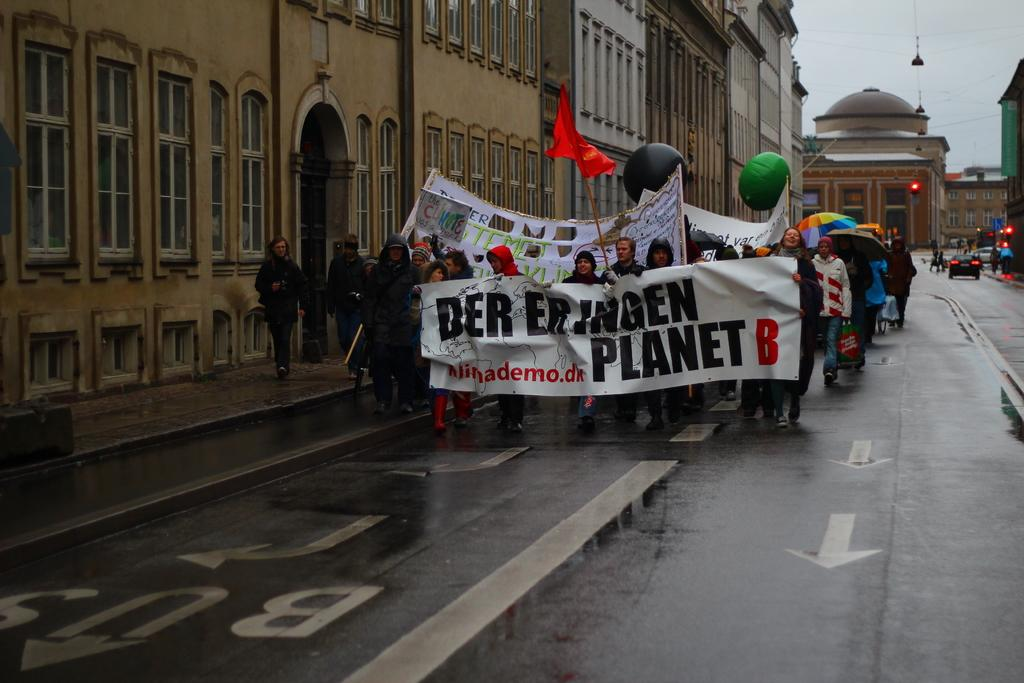What is the main subject in the foreground of the image? There is a crowd in the foreground of the image. What are the people in the crowd holding? The crowd is holding banners and flags. What is the crowd doing in the image? The crowd is moving on the road. What can be seen in the background of the image? There are buildings, lights, vehicles, cables, and the sky visible in the background. What type of book can be seen in the hands of the people in the crowd? There is no book visible in the hands of the people in the crowd; they are holding banners and flags. What is the crowd listening to in the image? The image does not provide any information about the crowd listening to something, as they are holding banners and flags and moving on the road. 